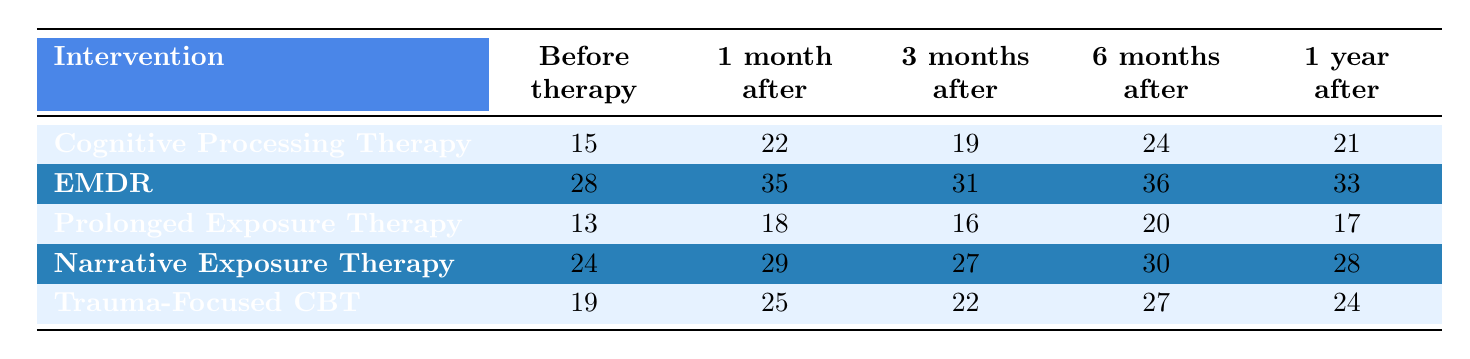What's the self-esteem score for Sarah before therapy? The table shows Sarah's self-esteem score in the row for "Cognitive Processing Therapy," under the column "Before therapy," which indicates a score of 15.
Answer: 15 What intervention has the highest self-esteem score one month after therapy? Looking at the second column titled "1 month after," EMDR has the highest score of 35 compared to the other interventions.
Answer: EMDR What is the average self-esteem score for patients after 6 months of Trauma-Focused CBT? The self-esteem scores for Trauma-Focused CBT at different times include 19 (before), 25 (1 month), 22 (3 months), 27 (6 months), and 24 (1 year). Adding these scores gives a total of 117, and dividing by 5 gives an average of 23.4.
Answer: 23.4 Did any intervention show a decrease in self-esteem scores from before therapy to one year after? By comparing each intervention's score before therapy and one year after, Prolonged Exposure Therapy decreased from 13 to 17, indicating a decrease in the self-esteem score, as well as Trauma-Focused CBT, which was 19 and decreased to 24.
Answer: Yes What is the total change in self-esteem scores for Olivia across all time periods after Cognitive Processing Therapy? Olivia's scores from the table are 22 (before), 28 (1 month), 25 (3 months), 29 (6 months), and 35 (1 year). The total change is calculated by comparing her scores: (28-22) + (25-28) + (29-25) + (35-29) = 6 - 3 + 4 + 6 = 13 total change.
Answer: 13 Which intervention had the smallest self-esteem score at the 3 months after point? The scores at the third column "3 months after" indicate that Prolonged Exposure Therapy scored 16, which is lower than all other interventions' scores in that column.
Answer: Prolonged Exposure Therapy How much did David's self-esteem score improve by 1 year after EMDR? David's score before EMDR therapy was 28, and his score after one year was 33. The improvement is calculated by subtracting the two scores: 33 - 28 = 5.
Answer: 5 